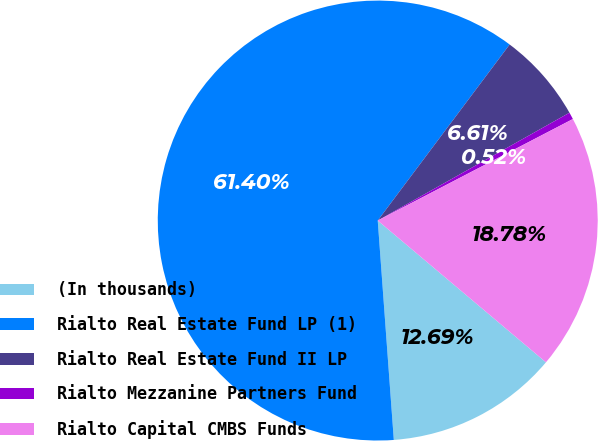<chart> <loc_0><loc_0><loc_500><loc_500><pie_chart><fcel>(In thousands)<fcel>Rialto Real Estate Fund LP (1)<fcel>Rialto Real Estate Fund II LP<fcel>Rialto Mezzanine Partners Fund<fcel>Rialto Capital CMBS Funds<nl><fcel>12.69%<fcel>61.4%<fcel>6.61%<fcel>0.52%<fcel>18.78%<nl></chart> 